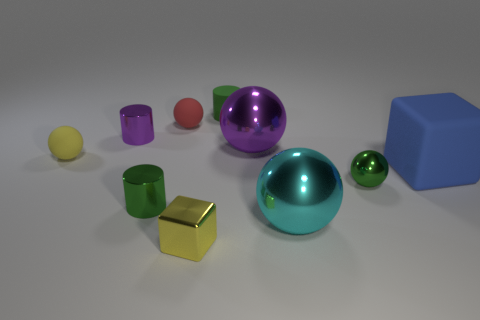Is there a pattern to the arrangement of the objects? The objects appear to be arranged randomly, but there is a slight clustering of similar shapes and a variation of sizes from small to large which could suggest an attempt at creating an aesthetically pleasing composition. 